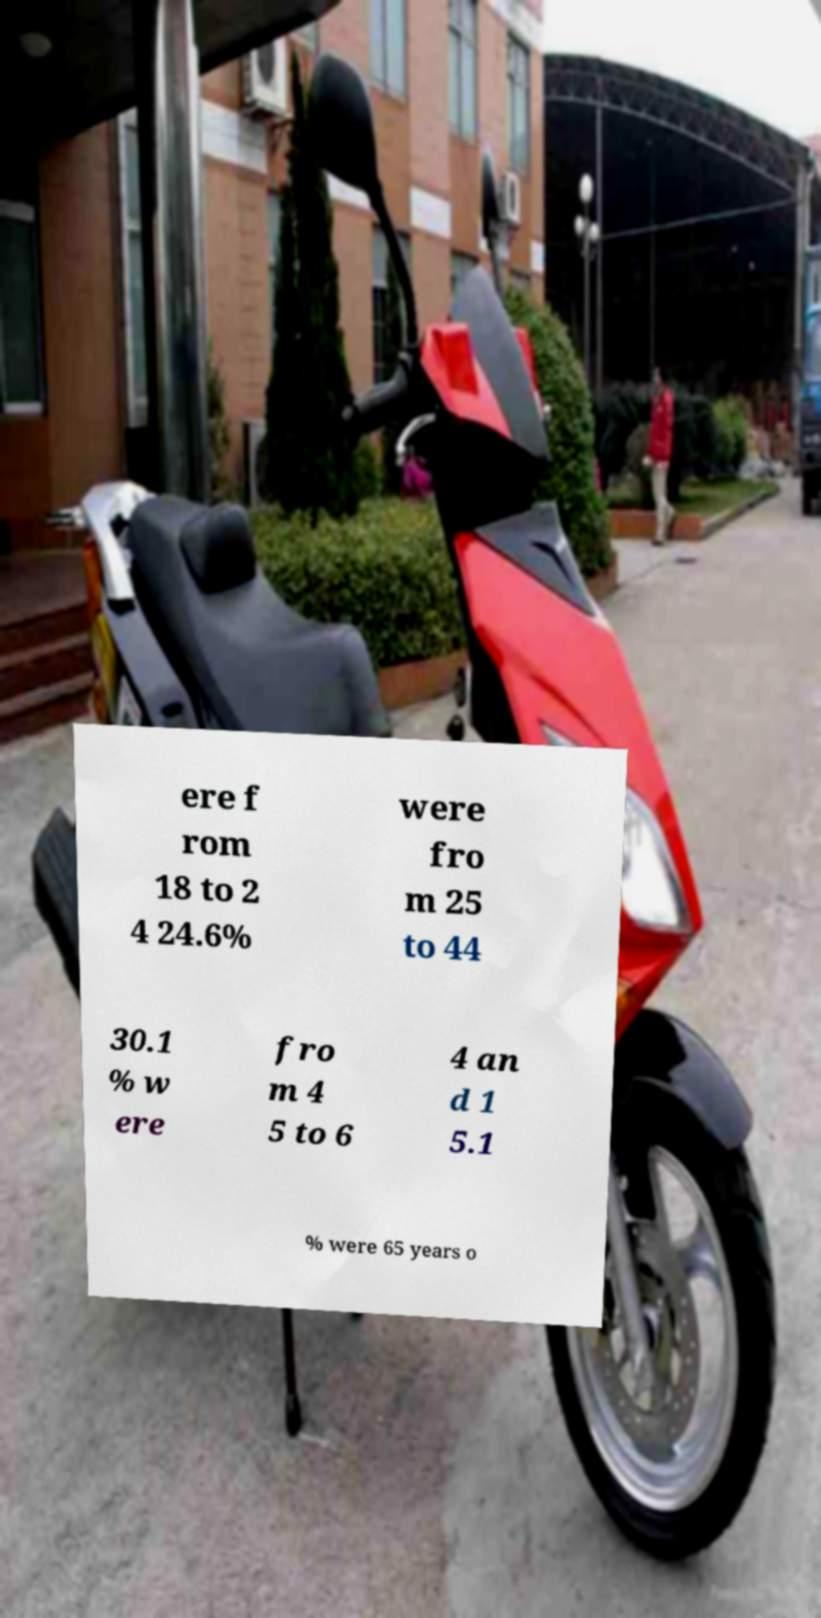Could you extract and type out the text from this image? ere f rom 18 to 2 4 24.6% were fro m 25 to 44 30.1 % w ere fro m 4 5 to 6 4 an d 1 5.1 % were 65 years o 